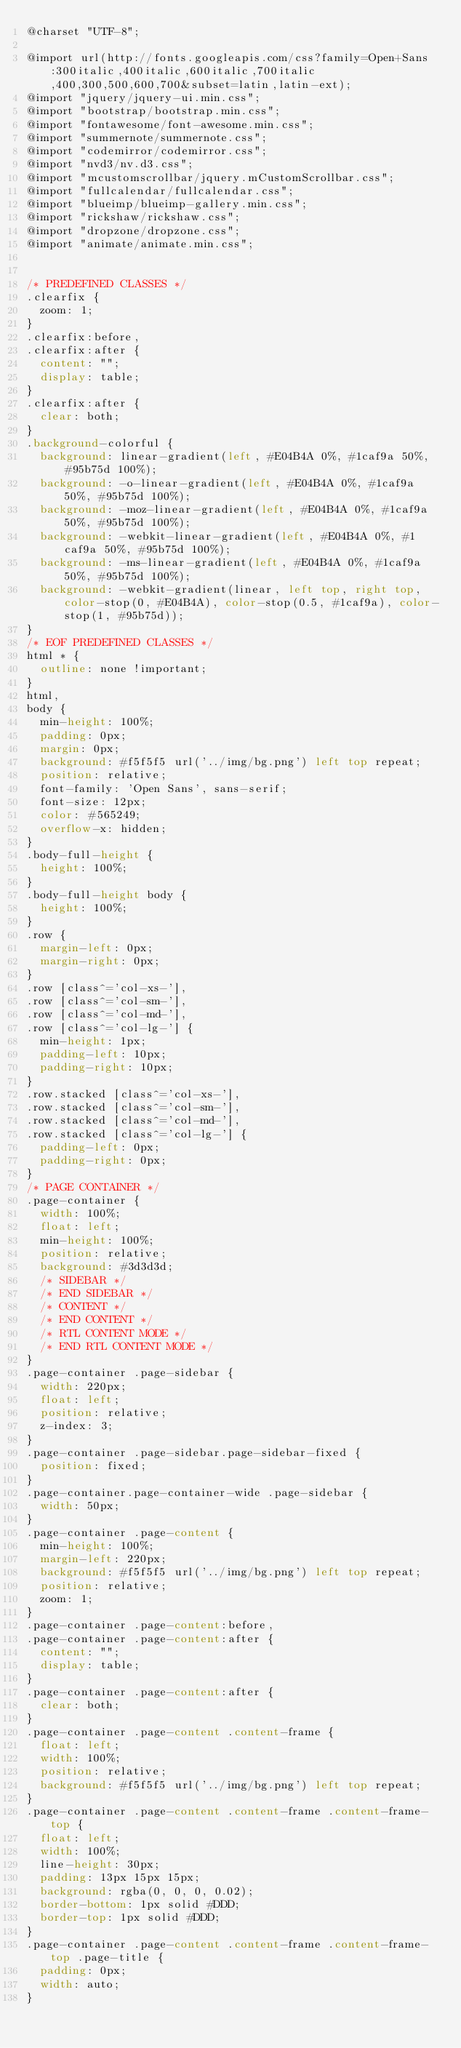<code> <loc_0><loc_0><loc_500><loc_500><_CSS_>@charset "UTF-8";

@import url(http://fonts.googleapis.com/css?family=Open+Sans:300italic,400italic,600italic,700italic,400,300,500,600,700&subset=latin,latin-ext);
@import "jquery/jquery-ui.min.css";
@import "bootstrap/bootstrap.min.css";
@import "fontawesome/font-awesome.min.css";
@import "summernote/summernote.css";
@import "codemirror/codemirror.css";
@import "nvd3/nv.d3.css";
@import "mcustomscrollbar/jquery.mCustomScrollbar.css";
@import "fullcalendar/fullcalendar.css";
@import "blueimp/blueimp-gallery.min.css";
@import "rickshaw/rickshaw.css";
@import "dropzone/dropzone.css";
@import "animate/animate.min.css";


/* PREDEFINED CLASSES */
.clearfix {
  zoom: 1;
}
.clearfix:before,
.clearfix:after {
  content: "";
  display: table;
}
.clearfix:after {
  clear: both;
}
.background-colorful {
  background: linear-gradient(left, #E04B4A 0%, #1caf9a 50%, #95b75d 100%);
  background: -o-linear-gradient(left, #E04B4A 0%, #1caf9a 50%, #95b75d 100%);
  background: -moz-linear-gradient(left, #E04B4A 0%, #1caf9a 50%, #95b75d 100%);
  background: -webkit-linear-gradient(left, #E04B4A 0%, #1caf9a 50%, #95b75d 100%);
  background: -ms-linear-gradient(left, #E04B4A 0%, #1caf9a 50%, #95b75d 100%);
  background: -webkit-gradient(linear, left top, right top, color-stop(0, #E04B4A), color-stop(0.5, #1caf9a), color-stop(1, #95b75d));
}
/* EOF PREDEFINED CLASSES */
html * {
  outline: none !important;
}
html,
body {
  min-height: 100%;
  padding: 0px;
  margin: 0px;
  background: #f5f5f5 url('../img/bg.png') left top repeat;
  position: relative;
  font-family: 'Open Sans', sans-serif;
  font-size: 12px;
  color: #565249;
  overflow-x: hidden;
}
.body-full-height {
  height: 100%;
}
.body-full-height body {
  height: 100%;
}
.row {
  margin-left: 0px;
  margin-right: 0px;
}
.row [class^='col-xs-'],
.row [class^='col-sm-'],
.row [class^='col-md-'],
.row [class^='col-lg-'] {
  min-height: 1px;
  padding-left: 10px;
  padding-right: 10px;
}
.row.stacked [class^='col-xs-'],
.row.stacked [class^='col-sm-'],
.row.stacked [class^='col-md-'],
.row.stacked [class^='col-lg-'] {
  padding-left: 0px;
  padding-right: 0px;
}
/* PAGE CONTAINER */
.page-container {
  width: 100%;
  float: left;
  min-height: 100%;
  position: relative;
  background: #3d3d3d;
  /* SIDEBAR */
  /* END SIDEBAR */
  /* CONTENT */
  /* END CONTENT */
  /* RTL CONTENT MODE */
  /* END RTL CONTENT MODE */
}
.page-container .page-sidebar {
  width: 220px;
  float: left;
  position: relative;
  z-index: 3;
}
.page-container .page-sidebar.page-sidebar-fixed {
  position: fixed;
}
.page-container.page-container-wide .page-sidebar {
  width: 50px;
}
.page-container .page-content {
  min-height: 100%;
  margin-left: 220px;
  background: #f5f5f5 url('../img/bg.png') left top repeat;
  position: relative;
  zoom: 1;
}
.page-container .page-content:before,
.page-container .page-content:after {
  content: "";
  display: table;
}
.page-container .page-content:after {
  clear: both;
}
.page-container .page-content .content-frame {
  float: left;
  width: 100%;
  position: relative;
  background: #f5f5f5 url('../img/bg.png') left top repeat;
}
.page-container .page-content .content-frame .content-frame-top {
  float: left;
  width: 100%;
  line-height: 30px;
  padding: 13px 15px 15px;
  background: rgba(0, 0, 0, 0.02);
  border-bottom: 1px solid #DDD;
  border-top: 1px solid #DDD;
}
.page-container .page-content .content-frame .content-frame-top .page-title {
  padding: 0px;
  width: auto;
}</code> 